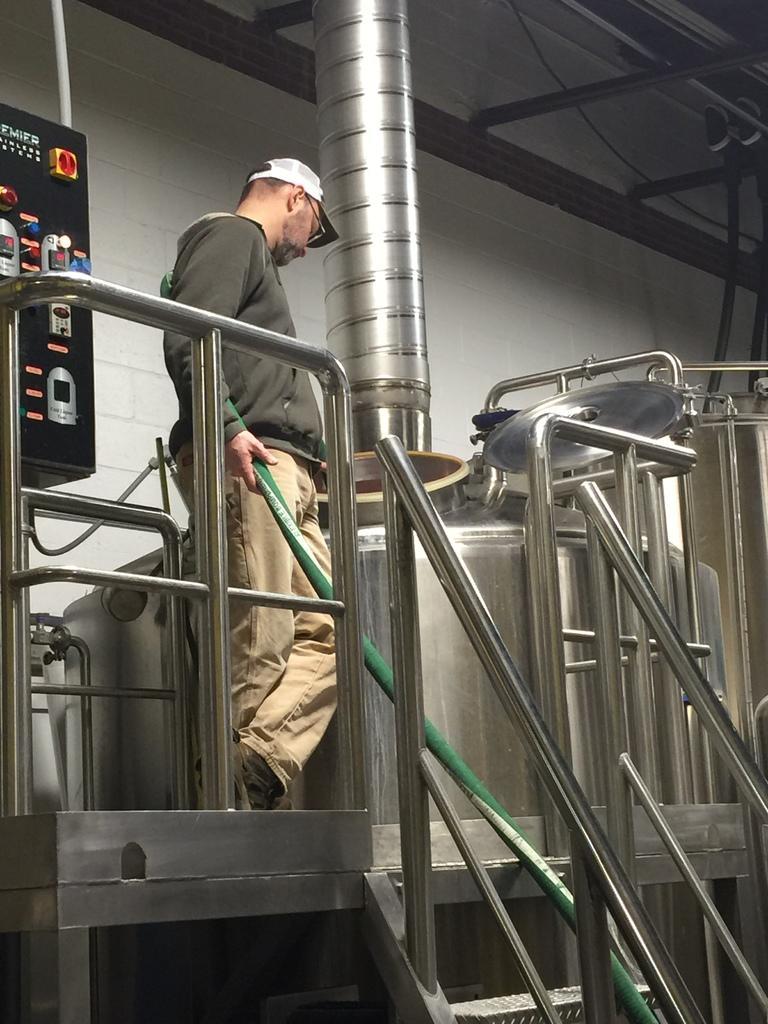Could you give a brief overview of what you see in this image? In this image, we can see a person standing and wearing glasses and a cap and holding a pipe. In the background, there are railings and we can see a tanker and there are switch boards. At the top, there is a roof. 